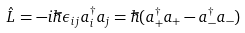<formula> <loc_0><loc_0><loc_500><loc_500>\hat { L } = - i \hbar { \epsilon } _ { i j } a _ { i } ^ { \dagger } a _ { j } = \hbar { ( } a _ { + } ^ { \dagger } a _ { + } - a _ { - } ^ { \dagger } a _ { - } )</formula> 